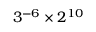<formula> <loc_0><loc_0><loc_500><loc_500>3 ^ { - 6 } \times 2 ^ { 1 0 }</formula> 